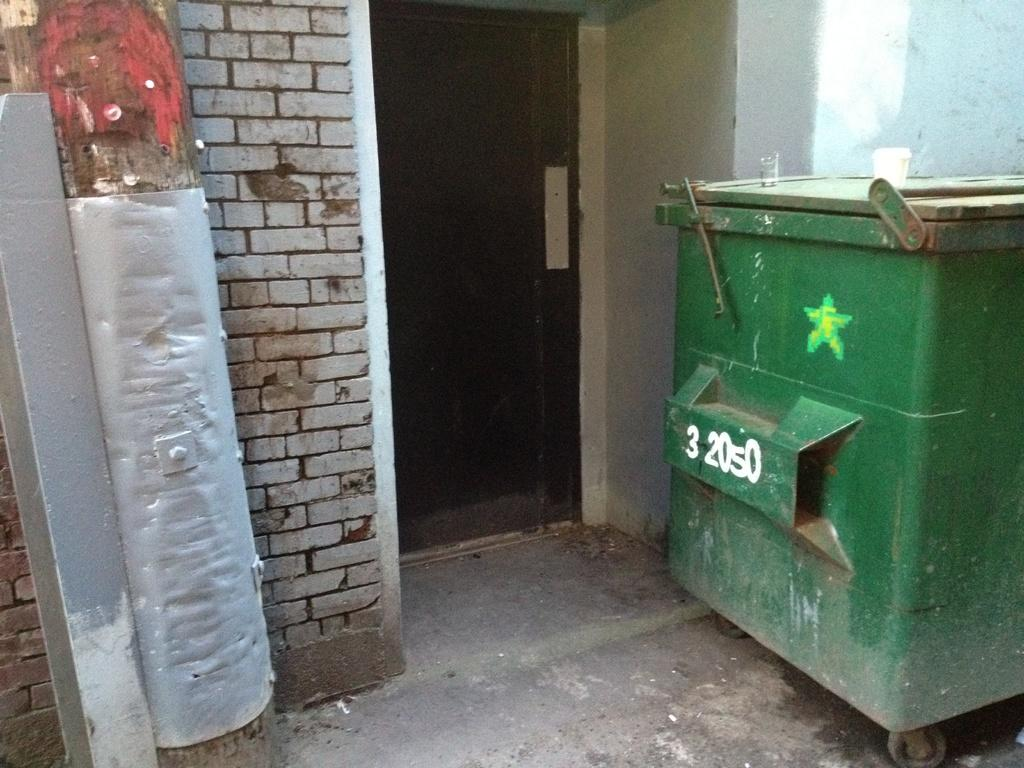Provide a one-sentence caption for the provided image. A green dumpster has the numbers 32050 painted on its side. 